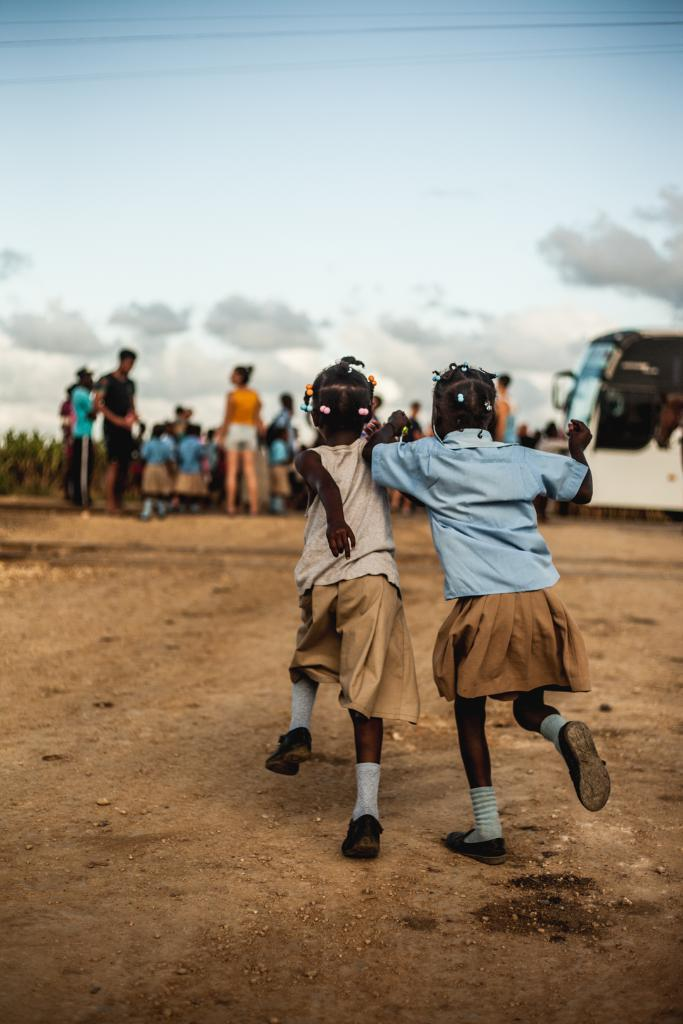How many kids are in the image? There are two kids in the image. What are the kids doing in the image? The kids are running. What are the kids wearing in the image? The kids are wearing dresses and shoes. What can be seen on the right side of the image? There is a vehicle on the right side of the image. What is visible at the top of the image? The sky is visible at the top of the image. What type of rings can be seen on the kids' fingers in the image? There are no rings visible on the kids' fingers in the image. Is there a tank present in the image? No, there is no tank present in the image. 